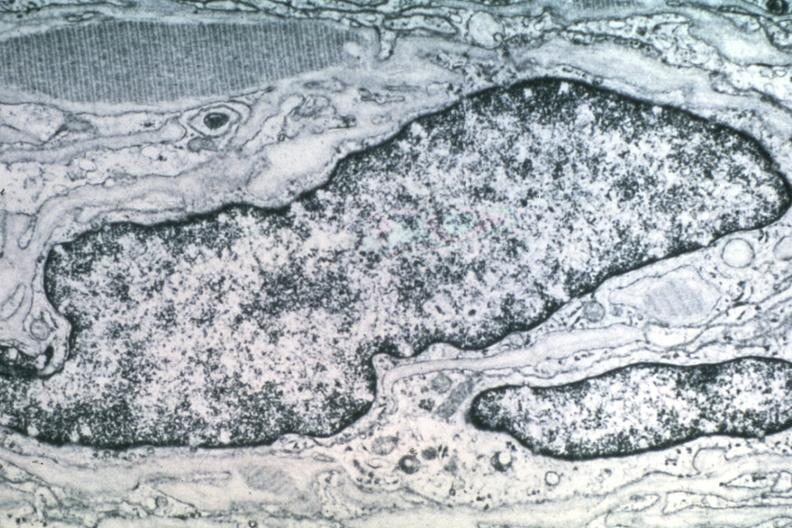s interesting case present?
Answer the question using a single word or phrase. No 